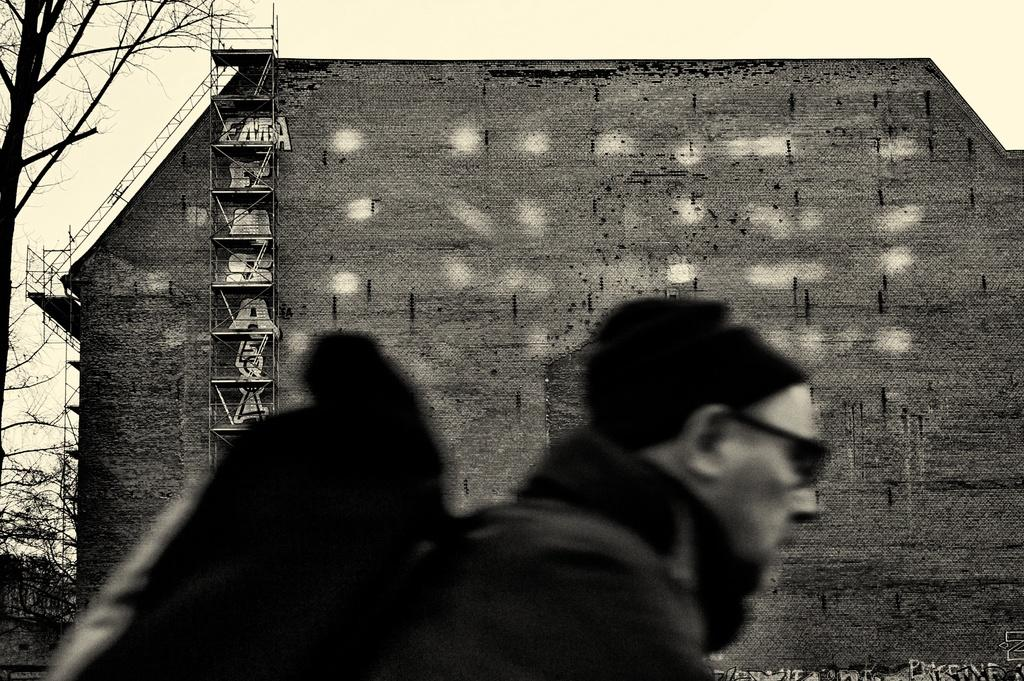Who is present in the image? There is a man in the image. What is the man wearing? The man is wearing a bag. What can be seen near the building in the image? There is a tree beside the building. What is visible in the background of the image? The sky is visible in the background of the image. What type of toys can be seen on the ladder in the image? There are no toys present in the image, and the ladder is not mentioned as having any objects on it. 